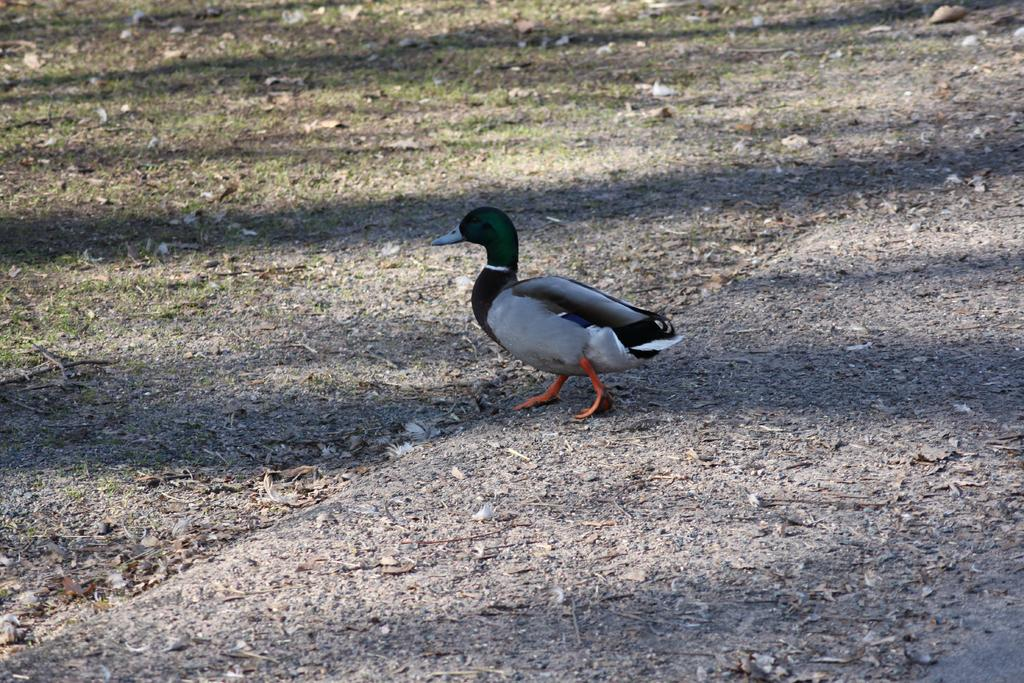What type of animal can be seen in the image? There is a bird in the image. What is the bird doing in the image? The bird is walking on the ground. What type of terrain is visible in the image? There is a slightly grassy land at the top left of the image. What type of collar is the bird wearing in the image? There is no collar present on the bird in the image. What type of drug is the bird consuming in the image? There is no drug present in the image, and the bird is not consuming anything. 